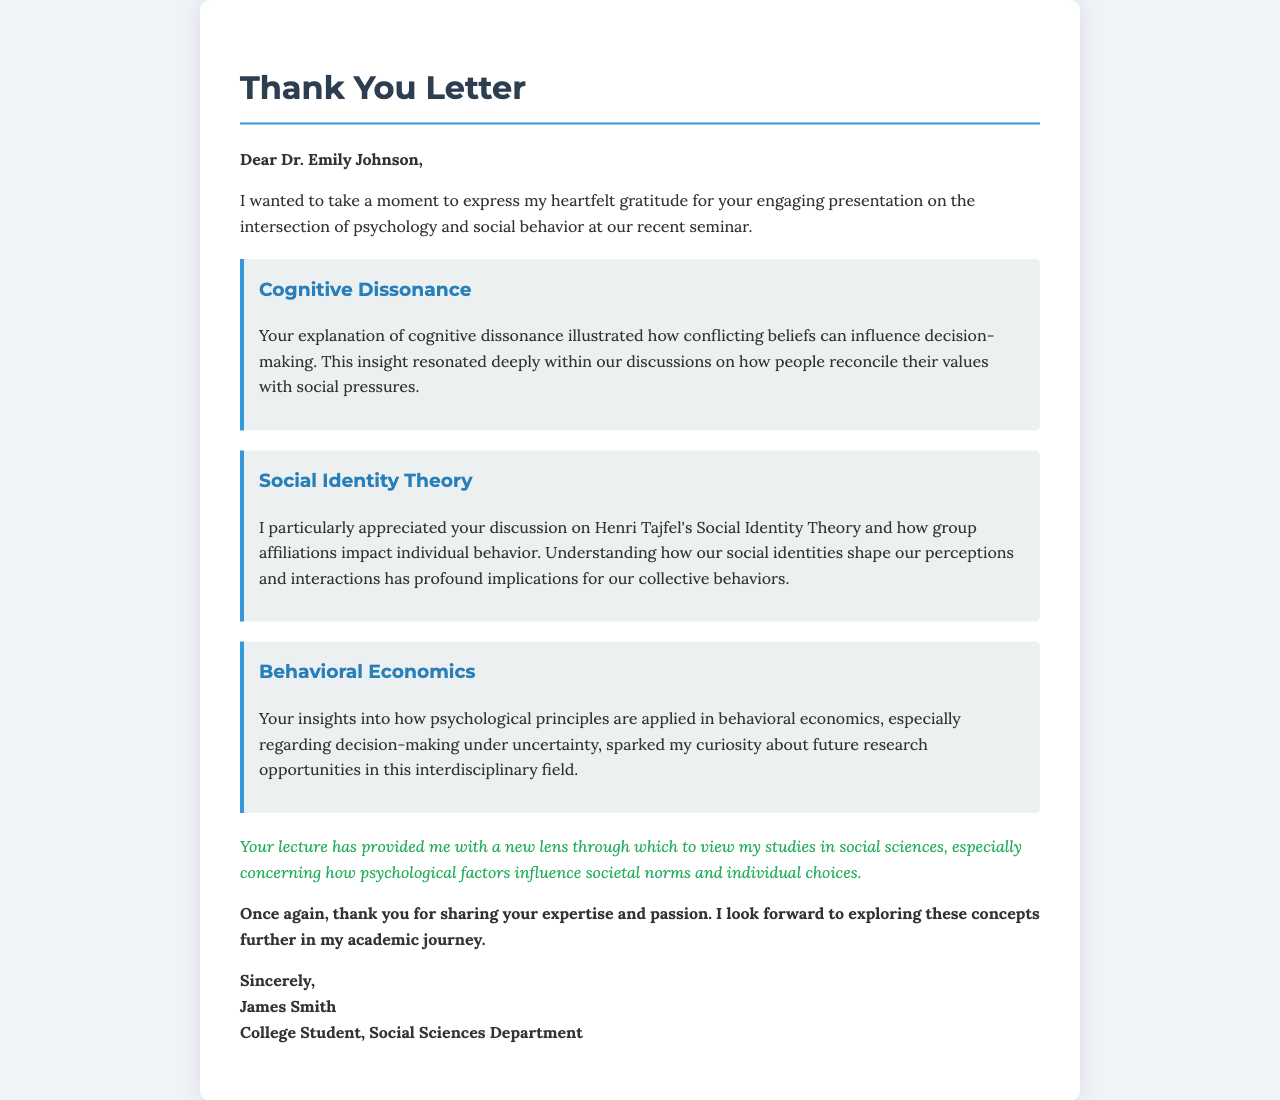What is the name of the guest speaker? The letter addresses Dr. Emily Johnson as the guest speaker.
Answer: Dr. Emily Johnson What were the three main topics discussed in the presentation? The letter mentions cognitive dissonance, Social Identity Theory, and behavioral economics as the main topics.
Answer: Cognitive dissonance, Social Identity Theory, behavioral economics Who is the author of the letter? The signature at the bottom identifies James Smith as the author.
Answer: James Smith What is the perspective the author gained from the lecture? The author expresses that the lecture provided a new lens to view studies in social sciences regarding psychological factors.
Answer: A new lens to view studies in social sciences What is the closing remark of the letter? The letter concludes with the author thanking the speaker and expressing anticipation for further exploration of the concepts.
Answer: Thank you for sharing your expertise and passion Which theoretical framework's impact on behavior is highlighted in the letter? The letter highlights Henri Tajfel's Social Identity Theory in relation to group affiliations and individual behavior.
Answer: Social Identity Theory What does the author appreciate about the discussion on behavioral economics? The author is curious about future research opportunities in behavioral economics as a result of the insights shared.
Answer: Curiosity about future research opportunities How does the author describe the impact of the lecture on their studies? The letter states that the lecture influenced the author's perspective on psychological factors affecting societal norms and choices.
Answer: Influenced the author's perspective on psychological factors 